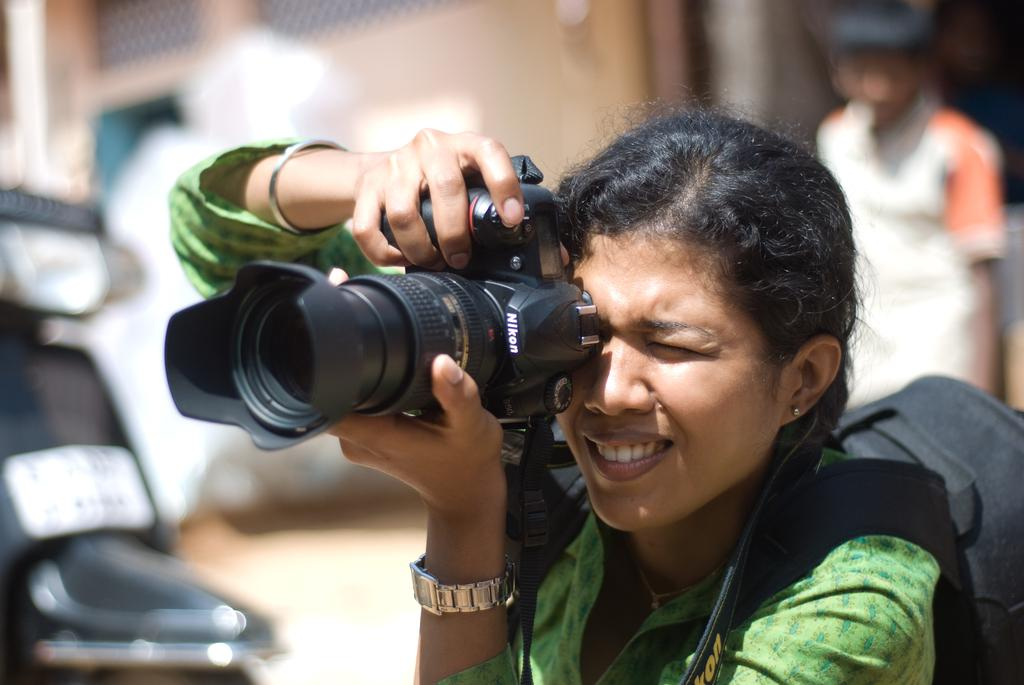Who is the main subject in the image? There is a woman in the image. What is the woman holding in the image? The woman is holding a camera. What color is the bag the woman is wearing? The woman is wearing a black color bag. Can you describe the person behind the woman in the image? There is a person standing behind the woman. What can be seen on the left side of the image? There is a scooter on the left side of the image. How does the woman wash the scooter in the image? There is no indication in the image that the woman is washing the scooter, and the scooter is on the left side of the image, not on the floor. 